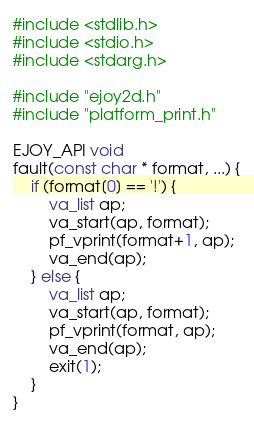<code> <loc_0><loc_0><loc_500><loc_500><_C_>#include <stdlib.h>
#include <stdio.h>
#include <stdarg.h>

#include "ejoy2d.h"
#include "platform_print.h"

EJOY_API void
fault(const char * format, ...) {
	if (format[0] == '!') {
		va_list ap;
		va_start(ap, format);
		pf_vprint(format+1, ap);
		va_end(ap);
	} else {
		va_list ap;
		va_start(ap, format);
		pf_vprint(format, ap);
		va_end(ap);
		exit(1);
	}
}

</code> 